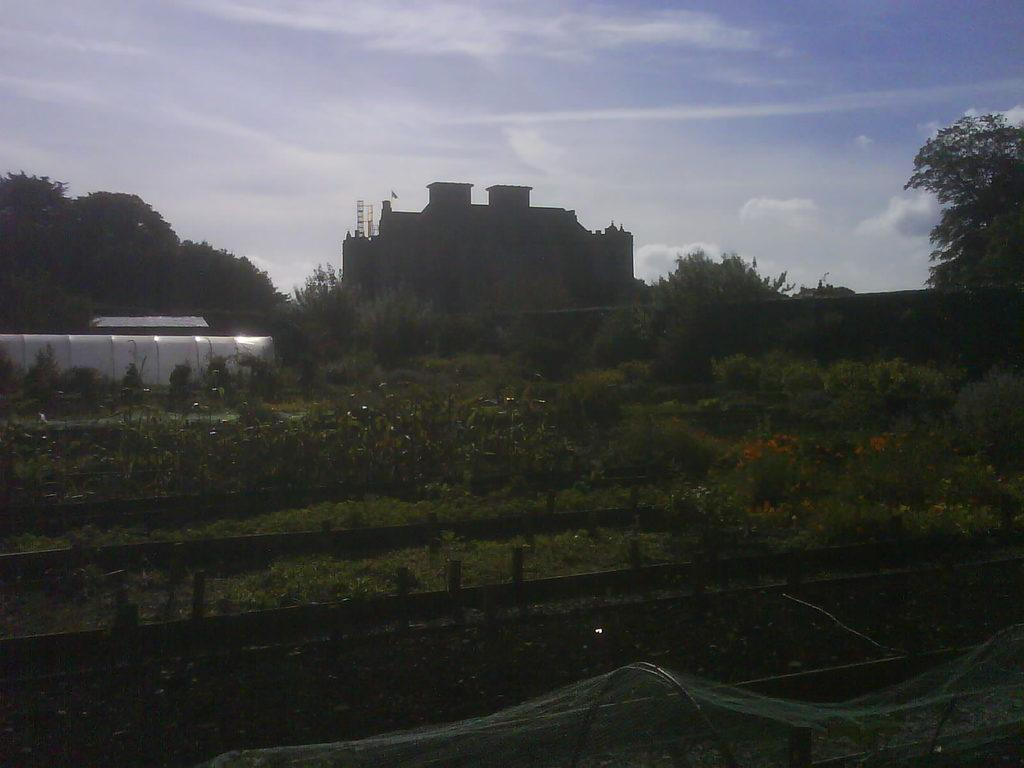What type of vegetation can be seen in the image? There is grass, plants, flowers, and trees in the image. What type of structure is present in the image? There is a building in the image. What is visible in the background of the image? The sky is visible in the background of the image. What type of yarn is being used to create the design on the building in the image? There is no yarn or design on the building in the image; it is a regular building with no visible decorations. What type of work is being done by the people in the image? There are no people present in the image, so it is not possible to determine what type of work they might be doing. 